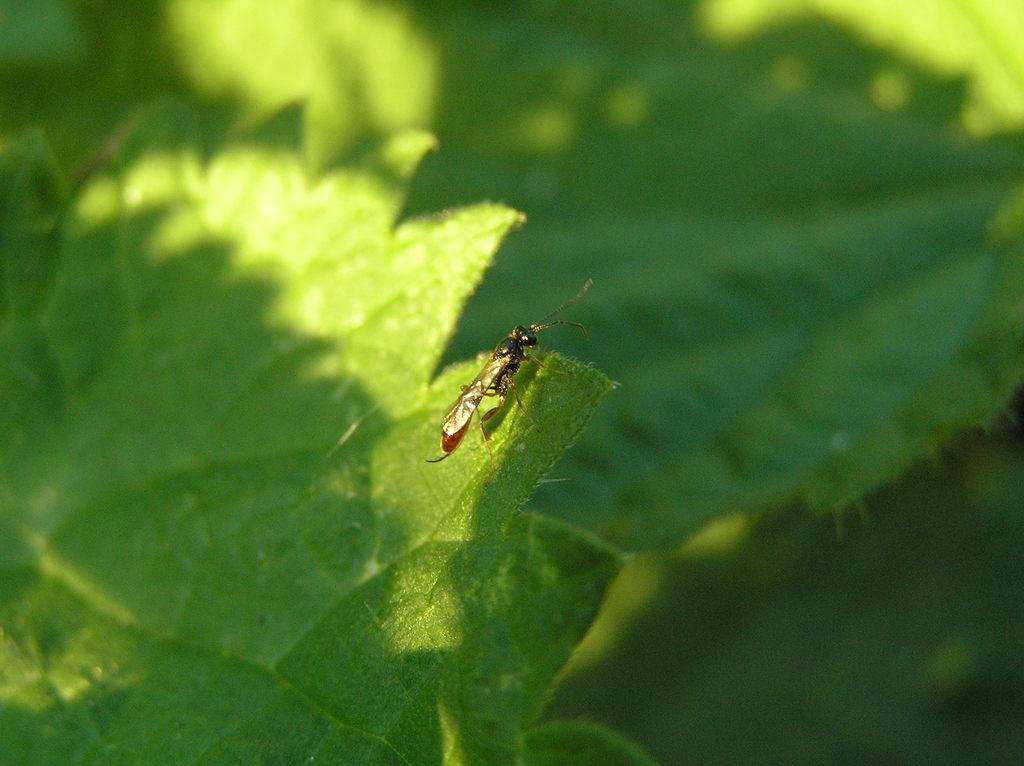What is on the leaf in the image? There is an insect on a leaf in the image. How would you describe the background of the image? The background of the image is blurred. What type of environment is depicted in the image? There is greenery visible in the image, suggesting a natural setting. How many bridges can be seen in the image? There are no bridges present in the image; it features an insect on a leaf with a blurred background and greenery. What type of knot is the insect using to hold onto the leaf? There is no knot present in the image; the insect is simply resting on the leaf. 